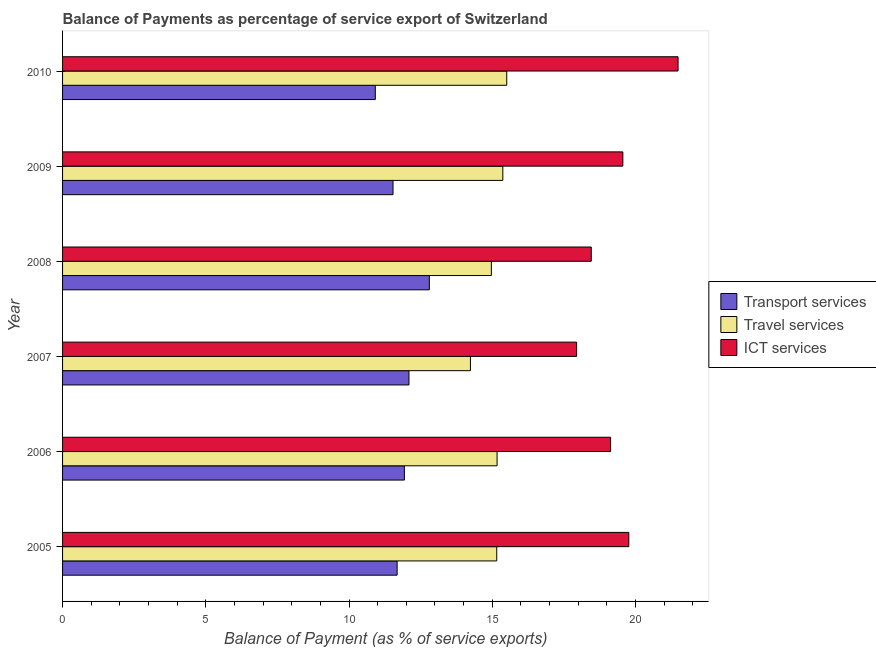Are the number of bars per tick equal to the number of legend labels?
Offer a very short reply. Yes. In how many cases, is the number of bars for a given year not equal to the number of legend labels?
Ensure brevity in your answer.  0. What is the balance of payment of travel services in 2008?
Offer a very short reply. 14.97. Across all years, what is the maximum balance of payment of transport services?
Give a very brief answer. 12.8. Across all years, what is the minimum balance of payment of travel services?
Ensure brevity in your answer.  14.24. In which year was the balance of payment of transport services maximum?
Give a very brief answer. 2008. In which year was the balance of payment of travel services minimum?
Make the answer very short. 2007. What is the total balance of payment of travel services in the graph?
Your response must be concise. 90.4. What is the difference between the balance of payment of travel services in 2007 and that in 2008?
Your response must be concise. -0.73. What is the difference between the balance of payment of ict services in 2009 and the balance of payment of travel services in 2005?
Keep it short and to the point. 4.4. What is the average balance of payment of travel services per year?
Ensure brevity in your answer.  15.07. In the year 2008, what is the difference between the balance of payment of ict services and balance of payment of transport services?
Provide a short and direct response. 5.65. What is the ratio of the balance of payment of ict services in 2008 to that in 2010?
Keep it short and to the point. 0.86. What is the difference between the highest and the second highest balance of payment of ict services?
Your response must be concise. 1.72. What is the difference between the highest and the lowest balance of payment of travel services?
Keep it short and to the point. 1.27. Is the sum of the balance of payment of transport services in 2007 and 2009 greater than the maximum balance of payment of travel services across all years?
Your response must be concise. Yes. What does the 1st bar from the top in 2008 represents?
Offer a terse response. ICT services. What does the 2nd bar from the bottom in 2007 represents?
Your answer should be very brief. Travel services. How many bars are there?
Your response must be concise. 18. Are all the bars in the graph horizontal?
Ensure brevity in your answer.  Yes. How many years are there in the graph?
Your answer should be very brief. 6. What is the difference between two consecutive major ticks on the X-axis?
Your answer should be very brief. 5. Are the values on the major ticks of X-axis written in scientific E-notation?
Your answer should be very brief. No. Does the graph contain any zero values?
Your answer should be compact. No. Does the graph contain grids?
Offer a terse response. No. Where does the legend appear in the graph?
Keep it short and to the point. Center right. How many legend labels are there?
Ensure brevity in your answer.  3. What is the title of the graph?
Make the answer very short. Balance of Payments as percentage of service export of Switzerland. What is the label or title of the X-axis?
Make the answer very short. Balance of Payment (as % of service exports). What is the label or title of the Y-axis?
Offer a very short reply. Year. What is the Balance of Payment (as % of service exports) of Transport services in 2005?
Ensure brevity in your answer.  11.68. What is the Balance of Payment (as % of service exports) in Travel services in 2005?
Provide a short and direct response. 15.16. What is the Balance of Payment (as % of service exports) in ICT services in 2005?
Make the answer very short. 19.77. What is the Balance of Payment (as % of service exports) of Transport services in 2006?
Provide a succinct answer. 11.93. What is the Balance of Payment (as % of service exports) in Travel services in 2006?
Make the answer very short. 15.17. What is the Balance of Payment (as % of service exports) in ICT services in 2006?
Give a very brief answer. 19.13. What is the Balance of Payment (as % of service exports) in Transport services in 2007?
Offer a terse response. 12.09. What is the Balance of Payment (as % of service exports) of Travel services in 2007?
Provide a succinct answer. 14.24. What is the Balance of Payment (as % of service exports) in ICT services in 2007?
Your response must be concise. 17.94. What is the Balance of Payment (as % of service exports) in Transport services in 2008?
Provide a succinct answer. 12.8. What is the Balance of Payment (as % of service exports) of Travel services in 2008?
Keep it short and to the point. 14.97. What is the Balance of Payment (as % of service exports) of ICT services in 2008?
Ensure brevity in your answer.  18.46. What is the Balance of Payment (as % of service exports) in Transport services in 2009?
Keep it short and to the point. 11.54. What is the Balance of Payment (as % of service exports) in Travel services in 2009?
Your response must be concise. 15.37. What is the Balance of Payment (as % of service exports) of ICT services in 2009?
Your answer should be compact. 19.56. What is the Balance of Payment (as % of service exports) in Transport services in 2010?
Make the answer very short. 10.92. What is the Balance of Payment (as % of service exports) of Travel services in 2010?
Give a very brief answer. 15.51. What is the Balance of Payment (as % of service exports) of ICT services in 2010?
Provide a succinct answer. 21.48. Across all years, what is the maximum Balance of Payment (as % of service exports) of Transport services?
Offer a very short reply. 12.8. Across all years, what is the maximum Balance of Payment (as % of service exports) of Travel services?
Your answer should be very brief. 15.51. Across all years, what is the maximum Balance of Payment (as % of service exports) of ICT services?
Keep it short and to the point. 21.48. Across all years, what is the minimum Balance of Payment (as % of service exports) of Transport services?
Make the answer very short. 10.92. Across all years, what is the minimum Balance of Payment (as % of service exports) in Travel services?
Your answer should be very brief. 14.24. Across all years, what is the minimum Balance of Payment (as % of service exports) of ICT services?
Your answer should be very brief. 17.94. What is the total Balance of Payment (as % of service exports) of Transport services in the graph?
Offer a terse response. 70.96. What is the total Balance of Payment (as % of service exports) of Travel services in the graph?
Offer a very short reply. 90.4. What is the total Balance of Payment (as % of service exports) of ICT services in the graph?
Keep it short and to the point. 116.34. What is the difference between the Balance of Payment (as % of service exports) in Transport services in 2005 and that in 2006?
Your response must be concise. -0.25. What is the difference between the Balance of Payment (as % of service exports) in Travel services in 2005 and that in 2006?
Offer a terse response. -0.01. What is the difference between the Balance of Payment (as % of service exports) in ICT services in 2005 and that in 2006?
Your answer should be compact. 0.64. What is the difference between the Balance of Payment (as % of service exports) of Transport services in 2005 and that in 2007?
Make the answer very short. -0.41. What is the difference between the Balance of Payment (as % of service exports) of Travel services in 2005 and that in 2007?
Give a very brief answer. 0.92. What is the difference between the Balance of Payment (as % of service exports) in ICT services in 2005 and that in 2007?
Ensure brevity in your answer.  1.82. What is the difference between the Balance of Payment (as % of service exports) of Transport services in 2005 and that in 2008?
Offer a terse response. -1.12. What is the difference between the Balance of Payment (as % of service exports) of Travel services in 2005 and that in 2008?
Offer a terse response. 0.19. What is the difference between the Balance of Payment (as % of service exports) in ICT services in 2005 and that in 2008?
Your answer should be very brief. 1.31. What is the difference between the Balance of Payment (as % of service exports) in Transport services in 2005 and that in 2009?
Provide a succinct answer. 0.14. What is the difference between the Balance of Payment (as % of service exports) of Travel services in 2005 and that in 2009?
Provide a short and direct response. -0.21. What is the difference between the Balance of Payment (as % of service exports) in ICT services in 2005 and that in 2009?
Your answer should be very brief. 0.21. What is the difference between the Balance of Payment (as % of service exports) in Transport services in 2005 and that in 2010?
Keep it short and to the point. 0.76. What is the difference between the Balance of Payment (as % of service exports) of Travel services in 2005 and that in 2010?
Keep it short and to the point. -0.35. What is the difference between the Balance of Payment (as % of service exports) of ICT services in 2005 and that in 2010?
Make the answer very short. -1.72. What is the difference between the Balance of Payment (as % of service exports) of Transport services in 2006 and that in 2007?
Provide a short and direct response. -0.16. What is the difference between the Balance of Payment (as % of service exports) of Travel services in 2006 and that in 2007?
Your answer should be compact. 0.93. What is the difference between the Balance of Payment (as % of service exports) in ICT services in 2006 and that in 2007?
Your response must be concise. 1.19. What is the difference between the Balance of Payment (as % of service exports) of Transport services in 2006 and that in 2008?
Your response must be concise. -0.87. What is the difference between the Balance of Payment (as % of service exports) in Travel services in 2006 and that in 2008?
Make the answer very short. 0.2. What is the difference between the Balance of Payment (as % of service exports) of ICT services in 2006 and that in 2008?
Ensure brevity in your answer.  0.67. What is the difference between the Balance of Payment (as % of service exports) in Transport services in 2006 and that in 2009?
Keep it short and to the point. 0.4. What is the difference between the Balance of Payment (as % of service exports) of Travel services in 2006 and that in 2009?
Your response must be concise. -0.2. What is the difference between the Balance of Payment (as % of service exports) in ICT services in 2006 and that in 2009?
Your response must be concise. -0.43. What is the difference between the Balance of Payment (as % of service exports) of Transport services in 2006 and that in 2010?
Make the answer very short. 1.01. What is the difference between the Balance of Payment (as % of service exports) in Travel services in 2006 and that in 2010?
Your answer should be compact. -0.34. What is the difference between the Balance of Payment (as % of service exports) of ICT services in 2006 and that in 2010?
Give a very brief answer. -2.36. What is the difference between the Balance of Payment (as % of service exports) in Transport services in 2007 and that in 2008?
Offer a terse response. -0.71. What is the difference between the Balance of Payment (as % of service exports) in Travel services in 2007 and that in 2008?
Keep it short and to the point. -0.73. What is the difference between the Balance of Payment (as % of service exports) of ICT services in 2007 and that in 2008?
Your answer should be compact. -0.51. What is the difference between the Balance of Payment (as % of service exports) of Transport services in 2007 and that in 2009?
Offer a very short reply. 0.56. What is the difference between the Balance of Payment (as % of service exports) in Travel services in 2007 and that in 2009?
Keep it short and to the point. -1.13. What is the difference between the Balance of Payment (as % of service exports) in ICT services in 2007 and that in 2009?
Your response must be concise. -1.61. What is the difference between the Balance of Payment (as % of service exports) in Transport services in 2007 and that in 2010?
Provide a short and direct response. 1.17. What is the difference between the Balance of Payment (as % of service exports) of Travel services in 2007 and that in 2010?
Make the answer very short. -1.27. What is the difference between the Balance of Payment (as % of service exports) in ICT services in 2007 and that in 2010?
Keep it short and to the point. -3.54. What is the difference between the Balance of Payment (as % of service exports) of Transport services in 2008 and that in 2009?
Give a very brief answer. 1.27. What is the difference between the Balance of Payment (as % of service exports) in Travel services in 2008 and that in 2009?
Provide a succinct answer. -0.4. What is the difference between the Balance of Payment (as % of service exports) in ICT services in 2008 and that in 2009?
Ensure brevity in your answer.  -1.1. What is the difference between the Balance of Payment (as % of service exports) in Transport services in 2008 and that in 2010?
Your answer should be very brief. 1.89. What is the difference between the Balance of Payment (as % of service exports) of Travel services in 2008 and that in 2010?
Provide a succinct answer. -0.54. What is the difference between the Balance of Payment (as % of service exports) of ICT services in 2008 and that in 2010?
Ensure brevity in your answer.  -3.03. What is the difference between the Balance of Payment (as % of service exports) in Transport services in 2009 and that in 2010?
Your answer should be compact. 0.62. What is the difference between the Balance of Payment (as % of service exports) in Travel services in 2009 and that in 2010?
Ensure brevity in your answer.  -0.14. What is the difference between the Balance of Payment (as % of service exports) of ICT services in 2009 and that in 2010?
Your answer should be compact. -1.93. What is the difference between the Balance of Payment (as % of service exports) of Transport services in 2005 and the Balance of Payment (as % of service exports) of Travel services in 2006?
Your answer should be compact. -3.49. What is the difference between the Balance of Payment (as % of service exports) in Transport services in 2005 and the Balance of Payment (as % of service exports) in ICT services in 2006?
Your response must be concise. -7.45. What is the difference between the Balance of Payment (as % of service exports) in Travel services in 2005 and the Balance of Payment (as % of service exports) in ICT services in 2006?
Ensure brevity in your answer.  -3.97. What is the difference between the Balance of Payment (as % of service exports) in Transport services in 2005 and the Balance of Payment (as % of service exports) in Travel services in 2007?
Offer a very short reply. -2.56. What is the difference between the Balance of Payment (as % of service exports) in Transport services in 2005 and the Balance of Payment (as % of service exports) in ICT services in 2007?
Your answer should be very brief. -6.27. What is the difference between the Balance of Payment (as % of service exports) of Travel services in 2005 and the Balance of Payment (as % of service exports) of ICT services in 2007?
Your response must be concise. -2.79. What is the difference between the Balance of Payment (as % of service exports) in Transport services in 2005 and the Balance of Payment (as % of service exports) in Travel services in 2008?
Your response must be concise. -3.29. What is the difference between the Balance of Payment (as % of service exports) of Transport services in 2005 and the Balance of Payment (as % of service exports) of ICT services in 2008?
Ensure brevity in your answer.  -6.78. What is the difference between the Balance of Payment (as % of service exports) in Travel services in 2005 and the Balance of Payment (as % of service exports) in ICT services in 2008?
Provide a short and direct response. -3.3. What is the difference between the Balance of Payment (as % of service exports) of Transport services in 2005 and the Balance of Payment (as % of service exports) of Travel services in 2009?
Offer a terse response. -3.69. What is the difference between the Balance of Payment (as % of service exports) of Transport services in 2005 and the Balance of Payment (as % of service exports) of ICT services in 2009?
Ensure brevity in your answer.  -7.88. What is the difference between the Balance of Payment (as % of service exports) of Travel services in 2005 and the Balance of Payment (as % of service exports) of ICT services in 2009?
Ensure brevity in your answer.  -4.4. What is the difference between the Balance of Payment (as % of service exports) in Transport services in 2005 and the Balance of Payment (as % of service exports) in Travel services in 2010?
Your answer should be compact. -3.83. What is the difference between the Balance of Payment (as % of service exports) of Transport services in 2005 and the Balance of Payment (as % of service exports) of ICT services in 2010?
Keep it short and to the point. -9.81. What is the difference between the Balance of Payment (as % of service exports) of Travel services in 2005 and the Balance of Payment (as % of service exports) of ICT services in 2010?
Ensure brevity in your answer.  -6.33. What is the difference between the Balance of Payment (as % of service exports) of Transport services in 2006 and the Balance of Payment (as % of service exports) of Travel services in 2007?
Give a very brief answer. -2.31. What is the difference between the Balance of Payment (as % of service exports) in Transport services in 2006 and the Balance of Payment (as % of service exports) in ICT services in 2007?
Your answer should be compact. -6.01. What is the difference between the Balance of Payment (as % of service exports) of Travel services in 2006 and the Balance of Payment (as % of service exports) of ICT services in 2007?
Make the answer very short. -2.78. What is the difference between the Balance of Payment (as % of service exports) in Transport services in 2006 and the Balance of Payment (as % of service exports) in Travel services in 2008?
Your response must be concise. -3.04. What is the difference between the Balance of Payment (as % of service exports) in Transport services in 2006 and the Balance of Payment (as % of service exports) in ICT services in 2008?
Offer a terse response. -6.52. What is the difference between the Balance of Payment (as % of service exports) in Travel services in 2006 and the Balance of Payment (as % of service exports) in ICT services in 2008?
Your response must be concise. -3.29. What is the difference between the Balance of Payment (as % of service exports) in Transport services in 2006 and the Balance of Payment (as % of service exports) in Travel services in 2009?
Keep it short and to the point. -3.44. What is the difference between the Balance of Payment (as % of service exports) of Transport services in 2006 and the Balance of Payment (as % of service exports) of ICT services in 2009?
Provide a succinct answer. -7.63. What is the difference between the Balance of Payment (as % of service exports) in Travel services in 2006 and the Balance of Payment (as % of service exports) in ICT services in 2009?
Your answer should be very brief. -4.39. What is the difference between the Balance of Payment (as % of service exports) of Transport services in 2006 and the Balance of Payment (as % of service exports) of Travel services in 2010?
Your answer should be compact. -3.57. What is the difference between the Balance of Payment (as % of service exports) in Transport services in 2006 and the Balance of Payment (as % of service exports) in ICT services in 2010?
Make the answer very short. -9.55. What is the difference between the Balance of Payment (as % of service exports) of Travel services in 2006 and the Balance of Payment (as % of service exports) of ICT services in 2010?
Provide a succinct answer. -6.32. What is the difference between the Balance of Payment (as % of service exports) in Transport services in 2007 and the Balance of Payment (as % of service exports) in Travel services in 2008?
Your answer should be very brief. -2.88. What is the difference between the Balance of Payment (as % of service exports) of Transport services in 2007 and the Balance of Payment (as % of service exports) of ICT services in 2008?
Your response must be concise. -6.36. What is the difference between the Balance of Payment (as % of service exports) of Travel services in 2007 and the Balance of Payment (as % of service exports) of ICT services in 2008?
Your answer should be compact. -4.22. What is the difference between the Balance of Payment (as % of service exports) of Transport services in 2007 and the Balance of Payment (as % of service exports) of Travel services in 2009?
Your response must be concise. -3.28. What is the difference between the Balance of Payment (as % of service exports) of Transport services in 2007 and the Balance of Payment (as % of service exports) of ICT services in 2009?
Provide a short and direct response. -7.47. What is the difference between the Balance of Payment (as % of service exports) of Travel services in 2007 and the Balance of Payment (as % of service exports) of ICT services in 2009?
Keep it short and to the point. -5.32. What is the difference between the Balance of Payment (as % of service exports) in Transport services in 2007 and the Balance of Payment (as % of service exports) in Travel services in 2010?
Offer a very short reply. -3.41. What is the difference between the Balance of Payment (as % of service exports) of Transport services in 2007 and the Balance of Payment (as % of service exports) of ICT services in 2010?
Your response must be concise. -9.39. What is the difference between the Balance of Payment (as % of service exports) in Travel services in 2007 and the Balance of Payment (as % of service exports) in ICT services in 2010?
Provide a succinct answer. -7.25. What is the difference between the Balance of Payment (as % of service exports) in Transport services in 2008 and the Balance of Payment (as % of service exports) in Travel services in 2009?
Give a very brief answer. -2.57. What is the difference between the Balance of Payment (as % of service exports) of Transport services in 2008 and the Balance of Payment (as % of service exports) of ICT services in 2009?
Give a very brief answer. -6.75. What is the difference between the Balance of Payment (as % of service exports) in Travel services in 2008 and the Balance of Payment (as % of service exports) in ICT services in 2009?
Your answer should be very brief. -4.59. What is the difference between the Balance of Payment (as % of service exports) of Transport services in 2008 and the Balance of Payment (as % of service exports) of Travel services in 2010?
Ensure brevity in your answer.  -2.7. What is the difference between the Balance of Payment (as % of service exports) in Transport services in 2008 and the Balance of Payment (as % of service exports) in ICT services in 2010?
Provide a short and direct response. -8.68. What is the difference between the Balance of Payment (as % of service exports) of Travel services in 2008 and the Balance of Payment (as % of service exports) of ICT services in 2010?
Your answer should be compact. -6.52. What is the difference between the Balance of Payment (as % of service exports) in Transport services in 2009 and the Balance of Payment (as % of service exports) in Travel services in 2010?
Offer a very short reply. -3.97. What is the difference between the Balance of Payment (as % of service exports) in Transport services in 2009 and the Balance of Payment (as % of service exports) in ICT services in 2010?
Make the answer very short. -9.95. What is the difference between the Balance of Payment (as % of service exports) of Travel services in 2009 and the Balance of Payment (as % of service exports) of ICT services in 2010?
Ensure brevity in your answer.  -6.12. What is the average Balance of Payment (as % of service exports) of Transport services per year?
Offer a very short reply. 11.83. What is the average Balance of Payment (as % of service exports) of Travel services per year?
Your answer should be very brief. 15.07. What is the average Balance of Payment (as % of service exports) in ICT services per year?
Keep it short and to the point. 19.39. In the year 2005, what is the difference between the Balance of Payment (as % of service exports) in Transport services and Balance of Payment (as % of service exports) in Travel services?
Offer a very short reply. -3.48. In the year 2005, what is the difference between the Balance of Payment (as % of service exports) in Transport services and Balance of Payment (as % of service exports) in ICT services?
Ensure brevity in your answer.  -8.09. In the year 2005, what is the difference between the Balance of Payment (as % of service exports) of Travel services and Balance of Payment (as % of service exports) of ICT services?
Make the answer very short. -4.61. In the year 2006, what is the difference between the Balance of Payment (as % of service exports) of Transport services and Balance of Payment (as % of service exports) of Travel services?
Offer a very short reply. -3.24. In the year 2006, what is the difference between the Balance of Payment (as % of service exports) of Transport services and Balance of Payment (as % of service exports) of ICT services?
Offer a very short reply. -7.2. In the year 2006, what is the difference between the Balance of Payment (as % of service exports) in Travel services and Balance of Payment (as % of service exports) in ICT services?
Offer a very short reply. -3.96. In the year 2007, what is the difference between the Balance of Payment (as % of service exports) in Transport services and Balance of Payment (as % of service exports) in Travel services?
Provide a short and direct response. -2.15. In the year 2007, what is the difference between the Balance of Payment (as % of service exports) of Transport services and Balance of Payment (as % of service exports) of ICT services?
Offer a terse response. -5.85. In the year 2007, what is the difference between the Balance of Payment (as % of service exports) of Travel services and Balance of Payment (as % of service exports) of ICT services?
Your answer should be compact. -3.71. In the year 2008, what is the difference between the Balance of Payment (as % of service exports) of Transport services and Balance of Payment (as % of service exports) of Travel services?
Your answer should be compact. -2.16. In the year 2008, what is the difference between the Balance of Payment (as % of service exports) of Transport services and Balance of Payment (as % of service exports) of ICT services?
Provide a short and direct response. -5.65. In the year 2008, what is the difference between the Balance of Payment (as % of service exports) in Travel services and Balance of Payment (as % of service exports) in ICT services?
Offer a terse response. -3.49. In the year 2009, what is the difference between the Balance of Payment (as % of service exports) in Transport services and Balance of Payment (as % of service exports) in Travel services?
Make the answer very short. -3.83. In the year 2009, what is the difference between the Balance of Payment (as % of service exports) in Transport services and Balance of Payment (as % of service exports) in ICT services?
Provide a succinct answer. -8.02. In the year 2009, what is the difference between the Balance of Payment (as % of service exports) of Travel services and Balance of Payment (as % of service exports) of ICT services?
Provide a short and direct response. -4.19. In the year 2010, what is the difference between the Balance of Payment (as % of service exports) of Transport services and Balance of Payment (as % of service exports) of Travel services?
Provide a succinct answer. -4.59. In the year 2010, what is the difference between the Balance of Payment (as % of service exports) of Transport services and Balance of Payment (as % of service exports) of ICT services?
Your response must be concise. -10.57. In the year 2010, what is the difference between the Balance of Payment (as % of service exports) of Travel services and Balance of Payment (as % of service exports) of ICT services?
Give a very brief answer. -5.98. What is the ratio of the Balance of Payment (as % of service exports) of Transport services in 2005 to that in 2006?
Keep it short and to the point. 0.98. What is the ratio of the Balance of Payment (as % of service exports) of ICT services in 2005 to that in 2006?
Offer a terse response. 1.03. What is the ratio of the Balance of Payment (as % of service exports) of Transport services in 2005 to that in 2007?
Ensure brevity in your answer.  0.97. What is the ratio of the Balance of Payment (as % of service exports) of Travel services in 2005 to that in 2007?
Your response must be concise. 1.06. What is the ratio of the Balance of Payment (as % of service exports) in ICT services in 2005 to that in 2007?
Keep it short and to the point. 1.1. What is the ratio of the Balance of Payment (as % of service exports) in Transport services in 2005 to that in 2008?
Provide a succinct answer. 0.91. What is the ratio of the Balance of Payment (as % of service exports) of Travel services in 2005 to that in 2008?
Provide a succinct answer. 1.01. What is the ratio of the Balance of Payment (as % of service exports) in ICT services in 2005 to that in 2008?
Offer a very short reply. 1.07. What is the ratio of the Balance of Payment (as % of service exports) in Transport services in 2005 to that in 2009?
Give a very brief answer. 1.01. What is the ratio of the Balance of Payment (as % of service exports) in Travel services in 2005 to that in 2009?
Offer a very short reply. 0.99. What is the ratio of the Balance of Payment (as % of service exports) of ICT services in 2005 to that in 2009?
Give a very brief answer. 1.01. What is the ratio of the Balance of Payment (as % of service exports) of Transport services in 2005 to that in 2010?
Provide a short and direct response. 1.07. What is the ratio of the Balance of Payment (as % of service exports) in Travel services in 2005 to that in 2010?
Your answer should be very brief. 0.98. What is the ratio of the Balance of Payment (as % of service exports) of Travel services in 2006 to that in 2007?
Give a very brief answer. 1.07. What is the ratio of the Balance of Payment (as % of service exports) of ICT services in 2006 to that in 2007?
Give a very brief answer. 1.07. What is the ratio of the Balance of Payment (as % of service exports) in Transport services in 2006 to that in 2008?
Your answer should be very brief. 0.93. What is the ratio of the Balance of Payment (as % of service exports) of Travel services in 2006 to that in 2008?
Ensure brevity in your answer.  1.01. What is the ratio of the Balance of Payment (as % of service exports) of ICT services in 2006 to that in 2008?
Give a very brief answer. 1.04. What is the ratio of the Balance of Payment (as % of service exports) of Transport services in 2006 to that in 2009?
Make the answer very short. 1.03. What is the ratio of the Balance of Payment (as % of service exports) in Travel services in 2006 to that in 2009?
Keep it short and to the point. 0.99. What is the ratio of the Balance of Payment (as % of service exports) in ICT services in 2006 to that in 2009?
Give a very brief answer. 0.98. What is the ratio of the Balance of Payment (as % of service exports) in Transport services in 2006 to that in 2010?
Your answer should be compact. 1.09. What is the ratio of the Balance of Payment (as % of service exports) of Travel services in 2006 to that in 2010?
Provide a short and direct response. 0.98. What is the ratio of the Balance of Payment (as % of service exports) in ICT services in 2006 to that in 2010?
Make the answer very short. 0.89. What is the ratio of the Balance of Payment (as % of service exports) in Transport services in 2007 to that in 2008?
Your answer should be very brief. 0.94. What is the ratio of the Balance of Payment (as % of service exports) of Travel services in 2007 to that in 2008?
Provide a short and direct response. 0.95. What is the ratio of the Balance of Payment (as % of service exports) of ICT services in 2007 to that in 2008?
Provide a succinct answer. 0.97. What is the ratio of the Balance of Payment (as % of service exports) in Transport services in 2007 to that in 2009?
Your response must be concise. 1.05. What is the ratio of the Balance of Payment (as % of service exports) of Travel services in 2007 to that in 2009?
Ensure brevity in your answer.  0.93. What is the ratio of the Balance of Payment (as % of service exports) in ICT services in 2007 to that in 2009?
Give a very brief answer. 0.92. What is the ratio of the Balance of Payment (as % of service exports) of Transport services in 2007 to that in 2010?
Make the answer very short. 1.11. What is the ratio of the Balance of Payment (as % of service exports) in Travel services in 2007 to that in 2010?
Provide a short and direct response. 0.92. What is the ratio of the Balance of Payment (as % of service exports) in ICT services in 2007 to that in 2010?
Offer a terse response. 0.84. What is the ratio of the Balance of Payment (as % of service exports) in Transport services in 2008 to that in 2009?
Provide a short and direct response. 1.11. What is the ratio of the Balance of Payment (as % of service exports) in Travel services in 2008 to that in 2009?
Offer a very short reply. 0.97. What is the ratio of the Balance of Payment (as % of service exports) of ICT services in 2008 to that in 2009?
Provide a succinct answer. 0.94. What is the ratio of the Balance of Payment (as % of service exports) of Transport services in 2008 to that in 2010?
Make the answer very short. 1.17. What is the ratio of the Balance of Payment (as % of service exports) of Travel services in 2008 to that in 2010?
Offer a very short reply. 0.97. What is the ratio of the Balance of Payment (as % of service exports) in ICT services in 2008 to that in 2010?
Keep it short and to the point. 0.86. What is the ratio of the Balance of Payment (as % of service exports) of Transport services in 2009 to that in 2010?
Your response must be concise. 1.06. What is the ratio of the Balance of Payment (as % of service exports) of Travel services in 2009 to that in 2010?
Offer a very short reply. 0.99. What is the ratio of the Balance of Payment (as % of service exports) of ICT services in 2009 to that in 2010?
Give a very brief answer. 0.91. What is the difference between the highest and the second highest Balance of Payment (as % of service exports) in Transport services?
Keep it short and to the point. 0.71. What is the difference between the highest and the second highest Balance of Payment (as % of service exports) of Travel services?
Make the answer very short. 0.14. What is the difference between the highest and the second highest Balance of Payment (as % of service exports) in ICT services?
Your answer should be very brief. 1.72. What is the difference between the highest and the lowest Balance of Payment (as % of service exports) of Transport services?
Ensure brevity in your answer.  1.89. What is the difference between the highest and the lowest Balance of Payment (as % of service exports) of Travel services?
Keep it short and to the point. 1.27. What is the difference between the highest and the lowest Balance of Payment (as % of service exports) in ICT services?
Ensure brevity in your answer.  3.54. 